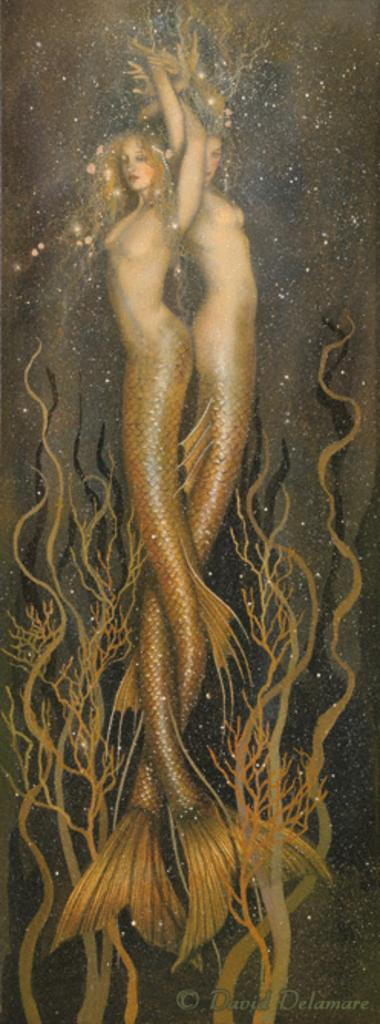What type of artwork is depicted in the image? The image is a painting. What mythical creatures can be seen in the painting? There are two mermaids in the painting. What type of vegetation is present in the painting? There are sea plants in the painting. Is there any additional marking on the image? Yes, there is a watermark on the image. What type of quiver can be seen in the painting? There is no quiver present in the painting; it features mermaids and sea plants. How many beetles can be seen crawling on the mermaids in the painting? There are no beetles present in the painting; it features mermaids and sea plants. 